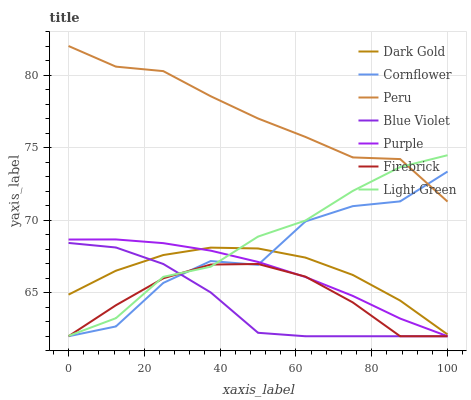Does Blue Violet have the minimum area under the curve?
Answer yes or no. Yes. Does Peru have the maximum area under the curve?
Answer yes or no. Yes. Does Light Green have the minimum area under the curve?
Answer yes or no. No. Does Light Green have the maximum area under the curve?
Answer yes or no. No. Is Purple the smoothest?
Answer yes or no. Yes. Is Cornflower the roughest?
Answer yes or no. Yes. Is Light Green the smoothest?
Answer yes or no. No. Is Light Green the roughest?
Answer yes or no. No. Does Cornflower have the lowest value?
Answer yes or no. Yes. Does Light Green have the lowest value?
Answer yes or no. No. Does Peru have the highest value?
Answer yes or no. Yes. Does Light Green have the highest value?
Answer yes or no. No. Is Firebrick less than Peru?
Answer yes or no. Yes. Is Peru greater than Dark Gold?
Answer yes or no. Yes. Does Purple intersect Light Green?
Answer yes or no. Yes. Is Purple less than Light Green?
Answer yes or no. No. Is Purple greater than Light Green?
Answer yes or no. No. Does Firebrick intersect Peru?
Answer yes or no. No. 